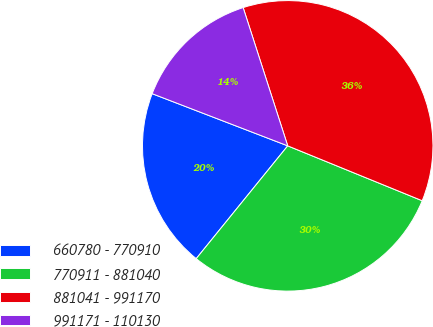Convert chart to OTSL. <chart><loc_0><loc_0><loc_500><loc_500><pie_chart><fcel>660780 - 770910<fcel>770911 - 881040<fcel>881041 - 991170<fcel>991171 - 110130<nl><fcel>20.0%<fcel>29.68%<fcel>36.13%<fcel>14.19%<nl></chart> 